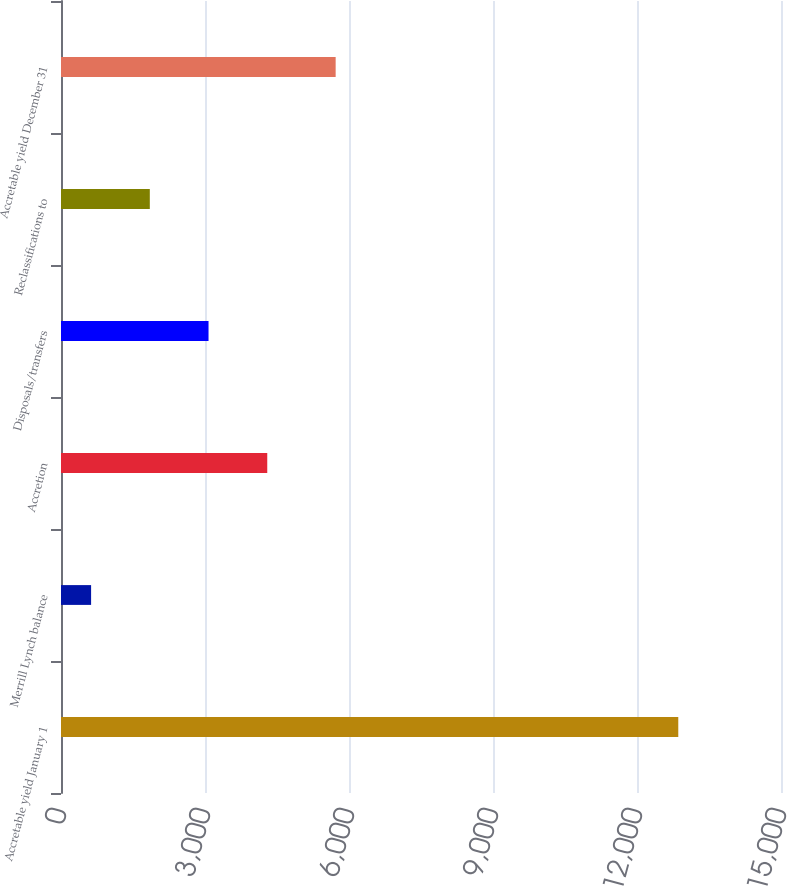Convert chart to OTSL. <chart><loc_0><loc_0><loc_500><loc_500><bar_chart><fcel>Accretable yield January 1<fcel>Merrill Lynch balance<fcel>Accretion<fcel>Disposals/transfers<fcel>Reclassifications to<fcel>Accretable yield December 31<nl><fcel>12860<fcel>627<fcel>4296.9<fcel>3073.6<fcel>1850.3<fcel>5722<nl></chart> 